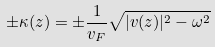Convert formula to latex. <formula><loc_0><loc_0><loc_500><loc_500>\pm \kappa ( z ) = \pm \frac { 1 } { v _ { F } } \sqrt { | v ( z ) | ^ { 2 } - \omega ^ { 2 } }</formula> 